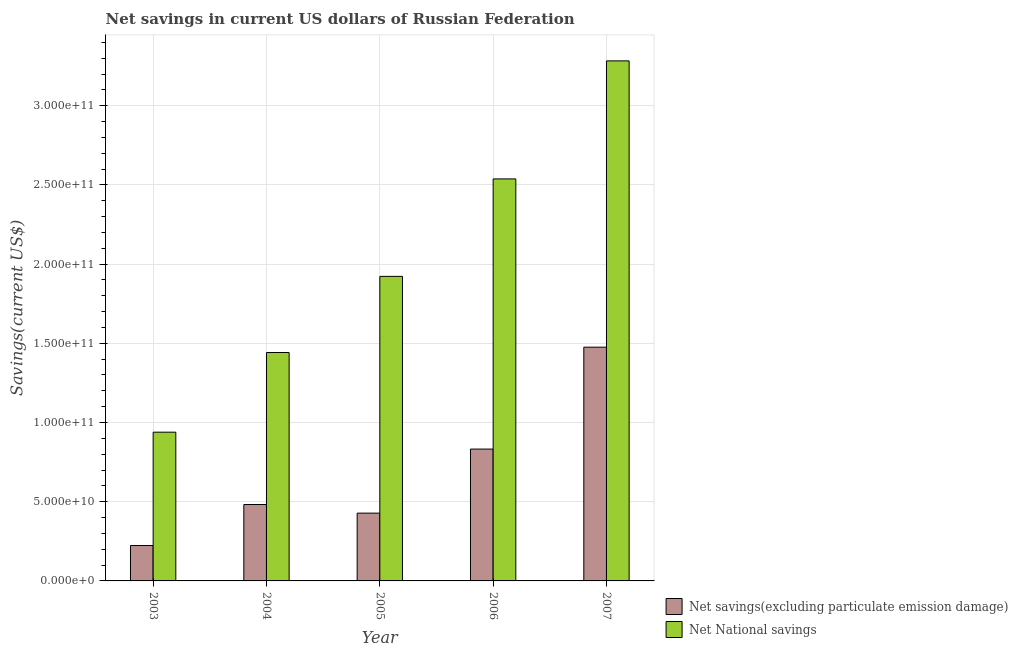Are the number of bars per tick equal to the number of legend labels?
Keep it short and to the point. Yes. How many bars are there on the 5th tick from the left?
Your answer should be very brief. 2. In how many cases, is the number of bars for a given year not equal to the number of legend labels?
Keep it short and to the point. 0. What is the net national savings in 2004?
Ensure brevity in your answer.  1.44e+11. Across all years, what is the maximum net savings(excluding particulate emission damage)?
Provide a short and direct response. 1.48e+11. Across all years, what is the minimum net savings(excluding particulate emission damage)?
Give a very brief answer. 2.24e+1. In which year was the net national savings maximum?
Offer a terse response. 2007. In which year was the net savings(excluding particulate emission damage) minimum?
Offer a terse response. 2003. What is the total net national savings in the graph?
Offer a very short reply. 1.01e+12. What is the difference between the net savings(excluding particulate emission damage) in 2005 and that in 2007?
Your response must be concise. -1.05e+11. What is the difference between the net national savings in 2004 and the net savings(excluding particulate emission damage) in 2003?
Your response must be concise. 5.03e+1. What is the average net national savings per year?
Your answer should be compact. 2.02e+11. What is the ratio of the net national savings in 2003 to that in 2004?
Provide a succinct answer. 0.65. Is the net savings(excluding particulate emission damage) in 2004 less than that in 2007?
Offer a terse response. Yes. What is the difference between the highest and the second highest net national savings?
Ensure brevity in your answer.  7.45e+1. What is the difference between the highest and the lowest net savings(excluding particulate emission damage)?
Your response must be concise. 1.25e+11. What does the 2nd bar from the left in 2005 represents?
Your response must be concise. Net National savings. What does the 2nd bar from the right in 2007 represents?
Give a very brief answer. Net savings(excluding particulate emission damage). Are all the bars in the graph horizontal?
Give a very brief answer. No. How many years are there in the graph?
Provide a succinct answer. 5. What is the difference between two consecutive major ticks on the Y-axis?
Provide a short and direct response. 5.00e+1. Are the values on the major ticks of Y-axis written in scientific E-notation?
Your answer should be very brief. Yes. Does the graph contain any zero values?
Your response must be concise. No. Does the graph contain grids?
Provide a succinct answer. Yes. How many legend labels are there?
Provide a succinct answer. 2. What is the title of the graph?
Provide a succinct answer. Net savings in current US dollars of Russian Federation. Does "Study and work" appear as one of the legend labels in the graph?
Offer a very short reply. No. What is the label or title of the X-axis?
Give a very brief answer. Year. What is the label or title of the Y-axis?
Offer a very short reply. Savings(current US$). What is the Savings(current US$) of Net savings(excluding particulate emission damage) in 2003?
Ensure brevity in your answer.  2.24e+1. What is the Savings(current US$) of Net National savings in 2003?
Your answer should be compact. 9.39e+1. What is the Savings(current US$) of Net savings(excluding particulate emission damage) in 2004?
Provide a short and direct response. 4.82e+1. What is the Savings(current US$) in Net National savings in 2004?
Provide a succinct answer. 1.44e+11. What is the Savings(current US$) of Net savings(excluding particulate emission damage) in 2005?
Your answer should be compact. 4.28e+1. What is the Savings(current US$) in Net National savings in 2005?
Offer a very short reply. 1.92e+11. What is the Savings(current US$) in Net savings(excluding particulate emission damage) in 2006?
Offer a terse response. 8.32e+1. What is the Savings(current US$) of Net National savings in 2006?
Offer a terse response. 2.54e+11. What is the Savings(current US$) of Net savings(excluding particulate emission damage) in 2007?
Offer a very short reply. 1.48e+11. What is the Savings(current US$) in Net National savings in 2007?
Give a very brief answer. 3.28e+11. Across all years, what is the maximum Savings(current US$) in Net savings(excluding particulate emission damage)?
Give a very brief answer. 1.48e+11. Across all years, what is the maximum Savings(current US$) of Net National savings?
Provide a succinct answer. 3.28e+11. Across all years, what is the minimum Savings(current US$) in Net savings(excluding particulate emission damage)?
Offer a terse response. 2.24e+1. Across all years, what is the minimum Savings(current US$) of Net National savings?
Your answer should be compact. 9.39e+1. What is the total Savings(current US$) of Net savings(excluding particulate emission damage) in the graph?
Make the answer very short. 3.44e+11. What is the total Savings(current US$) of Net National savings in the graph?
Offer a terse response. 1.01e+12. What is the difference between the Savings(current US$) of Net savings(excluding particulate emission damage) in 2003 and that in 2004?
Your answer should be very brief. -2.59e+1. What is the difference between the Savings(current US$) of Net National savings in 2003 and that in 2004?
Provide a succinct answer. -5.03e+1. What is the difference between the Savings(current US$) in Net savings(excluding particulate emission damage) in 2003 and that in 2005?
Your answer should be very brief. -2.04e+1. What is the difference between the Savings(current US$) in Net National savings in 2003 and that in 2005?
Your answer should be compact. -9.83e+1. What is the difference between the Savings(current US$) of Net savings(excluding particulate emission damage) in 2003 and that in 2006?
Provide a short and direct response. -6.09e+1. What is the difference between the Savings(current US$) of Net National savings in 2003 and that in 2006?
Make the answer very short. -1.60e+11. What is the difference between the Savings(current US$) in Net savings(excluding particulate emission damage) in 2003 and that in 2007?
Ensure brevity in your answer.  -1.25e+11. What is the difference between the Savings(current US$) of Net National savings in 2003 and that in 2007?
Your answer should be very brief. -2.34e+11. What is the difference between the Savings(current US$) of Net savings(excluding particulate emission damage) in 2004 and that in 2005?
Your answer should be compact. 5.44e+09. What is the difference between the Savings(current US$) in Net National savings in 2004 and that in 2005?
Offer a very short reply. -4.81e+1. What is the difference between the Savings(current US$) in Net savings(excluding particulate emission damage) in 2004 and that in 2006?
Keep it short and to the point. -3.50e+1. What is the difference between the Savings(current US$) of Net National savings in 2004 and that in 2006?
Provide a succinct answer. -1.10e+11. What is the difference between the Savings(current US$) of Net savings(excluding particulate emission damage) in 2004 and that in 2007?
Offer a terse response. -9.93e+1. What is the difference between the Savings(current US$) of Net National savings in 2004 and that in 2007?
Give a very brief answer. -1.84e+11. What is the difference between the Savings(current US$) of Net savings(excluding particulate emission damage) in 2005 and that in 2006?
Offer a very short reply. -4.04e+1. What is the difference between the Savings(current US$) of Net National savings in 2005 and that in 2006?
Make the answer very short. -6.15e+1. What is the difference between the Savings(current US$) of Net savings(excluding particulate emission damage) in 2005 and that in 2007?
Keep it short and to the point. -1.05e+11. What is the difference between the Savings(current US$) of Net National savings in 2005 and that in 2007?
Provide a short and direct response. -1.36e+11. What is the difference between the Savings(current US$) of Net savings(excluding particulate emission damage) in 2006 and that in 2007?
Your answer should be compact. -6.43e+1. What is the difference between the Savings(current US$) of Net National savings in 2006 and that in 2007?
Provide a succinct answer. -7.45e+1. What is the difference between the Savings(current US$) of Net savings(excluding particulate emission damage) in 2003 and the Savings(current US$) of Net National savings in 2004?
Offer a terse response. -1.22e+11. What is the difference between the Savings(current US$) in Net savings(excluding particulate emission damage) in 2003 and the Savings(current US$) in Net National savings in 2005?
Provide a succinct answer. -1.70e+11. What is the difference between the Savings(current US$) in Net savings(excluding particulate emission damage) in 2003 and the Savings(current US$) in Net National savings in 2006?
Offer a terse response. -2.31e+11. What is the difference between the Savings(current US$) of Net savings(excluding particulate emission damage) in 2003 and the Savings(current US$) of Net National savings in 2007?
Ensure brevity in your answer.  -3.06e+11. What is the difference between the Savings(current US$) of Net savings(excluding particulate emission damage) in 2004 and the Savings(current US$) of Net National savings in 2005?
Provide a short and direct response. -1.44e+11. What is the difference between the Savings(current US$) of Net savings(excluding particulate emission damage) in 2004 and the Savings(current US$) of Net National savings in 2006?
Your answer should be compact. -2.06e+11. What is the difference between the Savings(current US$) of Net savings(excluding particulate emission damage) in 2004 and the Savings(current US$) of Net National savings in 2007?
Offer a terse response. -2.80e+11. What is the difference between the Savings(current US$) of Net savings(excluding particulate emission damage) in 2005 and the Savings(current US$) of Net National savings in 2006?
Your answer should be compact. -2.11e+11. What is the difference between the Savings(current US$) in Net savings(excluding particulate emission damage) in 2005 and the Savings(current US$) in Net National savings in 2007?
Provide a succinct answer. -2.85e+11. What is the difference between the Savings(current US$) of Net savings(excluding particulate emission damage) in 2006 and the Savings(current US$) of Net National savings in 2007?
Provide a short and direct response. -2.45e+11. What is the average Savings(current US$) of Net savings(excluding particulate emission damage) per year?
Ensure brevity in your answer.  6.88e+1. What is the average Savings(current US$) of Net National savings per year?
Your response must be concise. 2.02e+11. In the year 2003, what is the difference between the Savings(current US$) in Net savings(excluding particulate emission damage) and Savings(current US$) in Net National savings?
Keep it short and to the point. -7.15e+1. In the year 2004, what is the difference between the Savings(current US$) in Net savings(excluding particulate emission damage) and Savings(current US$) in Net National savings?
Make the answer very short. -9.59e+1. In the year 2005, what is the difference between the Savings(current US$) in Net savings(excluding particulate emission damage) and Savings(current US$) in Net National savings?
Your answer should be very brief. -1.49e+11. In the year 2006, what is the difference between the Savings(current US$) of Net savings(excluding particulate emission damage) and Savings(current US$) of Net National savings?
Make the answer very short. -1.71e+11. In the year 2007, what is the difference between the Savings(current US$) in Net savings(excluding particulate emission damage) and Savings(current US$) in Net National savings?
Provide a short and direct response. -1.81e+11. What is the ratio of the Savings(current US$) of Net savings(excluding particulate emission damage) in 2003 to that in 2004?
Your response must be concise. 0.46. What is the ratio of the Savings(current US$) of Net National savings in 2003 to that in 2004?
Give a very brief answer. 0.65. What is the ratio of the Savings(current US$) of Net savings(excluding particulate emission damage) in 2003 to that in 2005?
Offer a terse response. 0.52. What is the ratio of the Savings(current US$) of Net National savings in 2003 to that in 2005?
Make the answer very short. 0.49. What is the ratio of the Savings(current US$) in Net savings(excluding particulate emission damage) in 2003 to that in 2006?
Offer a very short reply. 0.27. What is the ratio of the Savings(current US$) of Net National savings in 2003 to that in 2006?
Give a very brief answer. 0.37. What is the ratio of the Savings(current US$) in Net savings(excluding particulate emission damage) in 2003 to that in 2007?
Your answer should be very brief. 0.15. What is the ratio of the Savings(current US$) in Net National savings in 2003 to that in 2007?
Keep it short and to the point. 0.29. What is the ratio of the Savings(current US$) in Net savings(excluding particulate emission damage) in 2004 to that in 2005?
Give a very brief answer. 1.13. What is the ratio of the Savings(current US$) of Net National savings in 2004 to that in 2005?
Make the answer very short. 0.75. What is the ratio of the Savings(current US$) of Net savings(excluding particulate emission damage) in 2004 to that in 2006?
Keep it short and to the point. 0.58. What is the ratio of the Savings(current US$) in Net National savings in 2004 to that in 2006?
Give a very brief answer. 0.57. What is the ratio of the Savings(current US$) of Net savings(excluding particulate emission damage) in 2004 to that in 2007?
Give a very brief answer. 0.33. What is the ratio of the Savings(current US$) of Net National savings in 2004 to that in 2007?
Offer a terse response. 0.44. What is the ratio of the Savings(current US$) in Net savings(excluding particulate emission damage) in 2005 to that in 2006?
Your answer should be very brief. 0.51. What is the ratio of the Savings(current US$) in Net National savings in 2005 to that in 2006?
Offer a very short reply. 0.76. What is the ratio of the Savings(current US$) in Net savings(excluding particulate emission damage) in 2005 to that in 2007?
Your answer should be very brief. 0.29. What is the ratio of the Savings(current US$) of Net National savings in 2005 to that in 2007?
Ensure brevity in your answer.  0.59. What is the ratio of the Savings(current US$) in Net savings(excluding particulate emission damage) in 2006 to that in 2007?
Give a very brief answer. 0.56. What is the ratio of the Savings(current US$) in Net National savings in 2006 to that in 2007?
Give a very brief answer. 0.77. What is the difference between the highest and the second highest Savings(current US$) in Net savings(excluding particulate emission damage)?
Provide a succinct answer. 6.43e+1. What is the difference between the highest and the second highest Savings(current US$) of Net National savings?
Make the answer very short. 7.45e+1. What is the difference between the highest and the lowest Savings(current US$) of Net savings(excluding particulate emission damage)?
Your response must be concise. 1.25e+11. What is the difference between the highest and the lowest Savings(current US$) of Net National savings?
Give a very brief answer. 2.34e+11. 